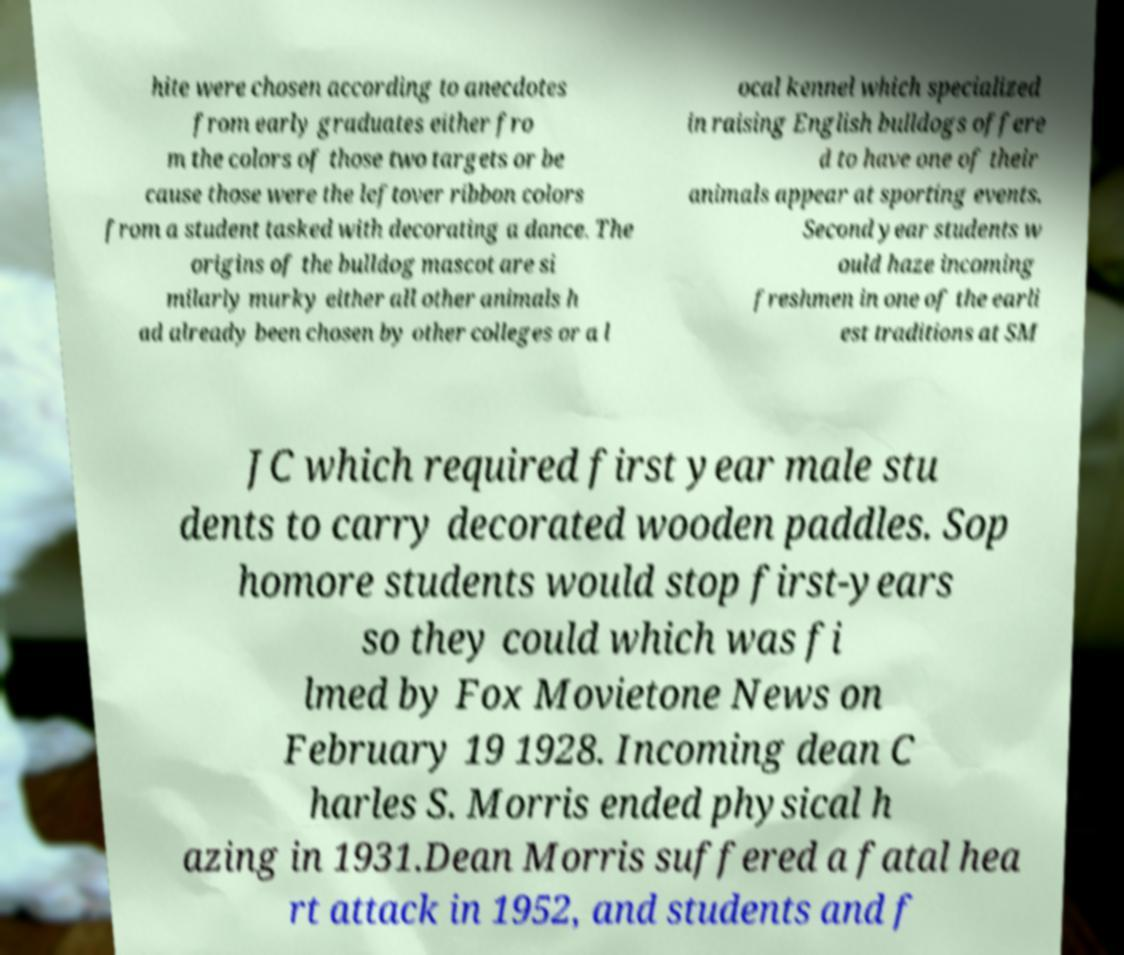Could you assist in decoding the text presented in this image and type it out clearly? hite were chosen according to anecdotes from early graduates either fro m the colors of those two targets or be cause those were the leftover ribbon colors from a student tasked with decorating a dance. The origins of the bulldog mascot are si milarly murky either all other animals h ad already been chosen by other colleges or a l ocal kennel which specialized in raising English bulldogs offere d to have one of their animals appear at sporting events. Second year students w ould haze incoming freshmen in one of the earli est traditions at SM JC which required first year male stu dents to carry decorated wooden paddles. Sop homore students would stop first-years so they could which was fi lmed by Fox Movietone News on February 19 1928. Incoming dean C harles S. Morris ended physical h azing in 1931.Dean Morris suffered a fatal hea rt attack in 1952, and students and f 